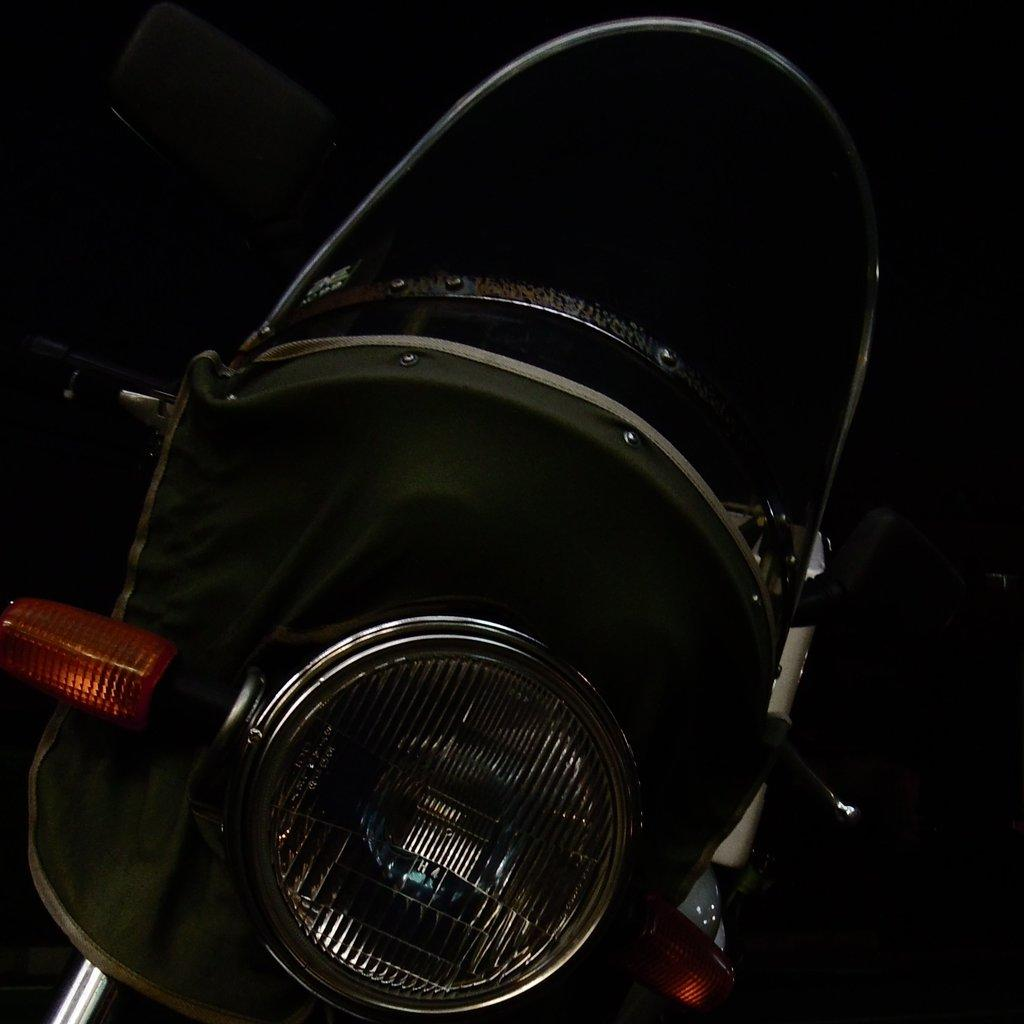What is the main subject of the image? The main subject of the image is a motorcycle. What can be observed about the background of the image? The background of the image is dark. How many cakes are being held by the motorcycle in the image? There are no cakes present in the image, and the motorcycle is not holding any objects. What type of error is depicted in the image? There is no error depicted in the image; it features a motorcycle and a dark background. 